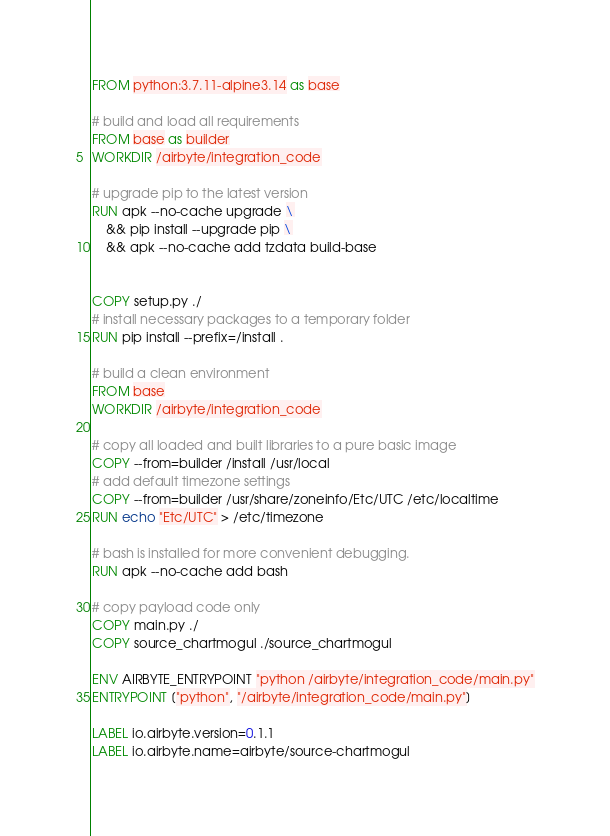<code> <loc_0><loc_0><loc_500><loc_500><_Dockerfile_>FROM python:3.7.11-alpine3.14 as base

# build and load all requirements
FROM base as builder
WORKDIR /airbyte/integration_code

# upgrade pip to the latest version
RUN apk --no-cache upgrade \
    && pip install --upgrade pip \
    && apk --no-cache add tzdata build-base


COPY setup.py ./
# install necessary packages to a temporary folder
RUN pip install --prefix=/install .

# build a clean environment
FROM base
WORKDIR /airbyte/integration_code

# copy all loaded and built libraries to a pure basic image
COPY --from=builder /install /usr/local
# add default timezone settings
COPY --from=builder /usr/share/zoneinfo/Etc/UTC /etc/localtime
RUN echo "Etc/UTC" > /etc/timezone

# bash is installed for more convenient debugging.
RUN apk --no-cache add bash

# copy payload code only
COPY main.py ./
COPY source_chartmogul ./source_chartmogul

ENV AIRBYTE_ENTRYPOINT "python /airbyte/integration_code/main.py"
ENTRYPOINT ["python", "/airbyte/integration_code/main.py"]

LABEL io.airbyte.version=0.1.1
LABEL io.airbyte.name=airbyte/source-chartmogul
</code> 